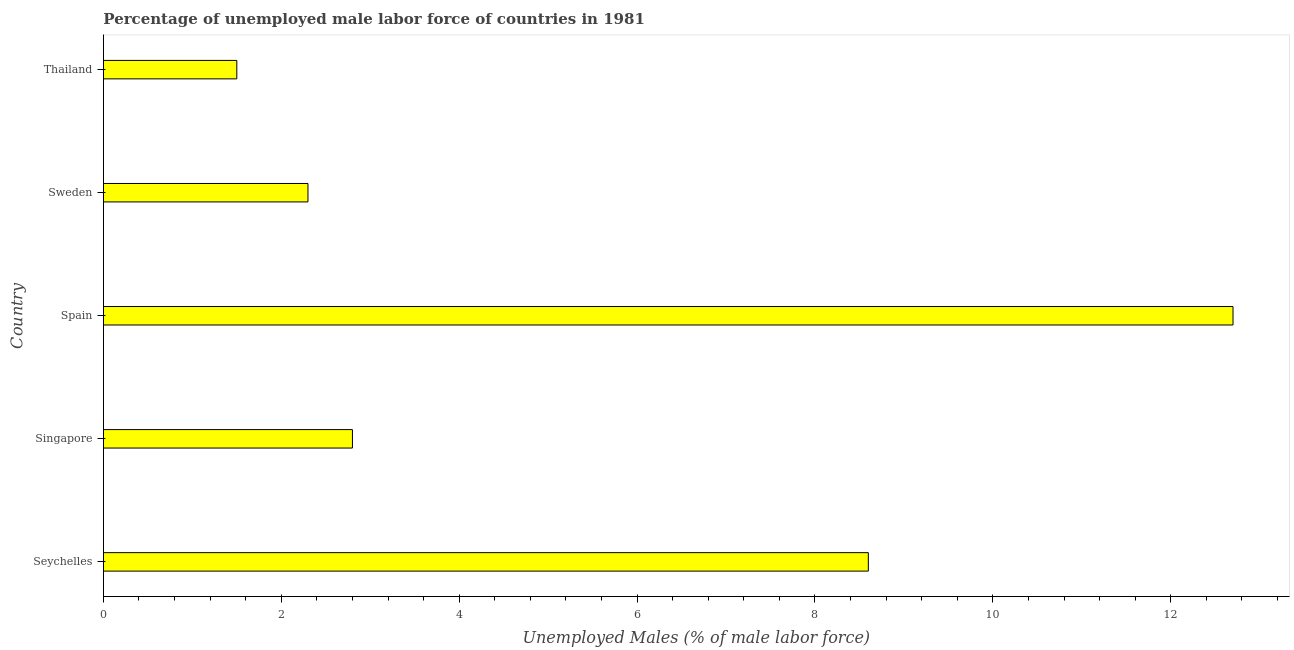Does the graph contain any zero values?
Offer a terse response. No. What is the title of the graph?
Offer a terse response. Percentage of unemployed male labor force of countries in 1981. What is the label or title of the X-axis?
Provide a short and direct response. Unemployed Males (% of male labor force). What is the total unemployed male labour force in Seychelles?
Ensure brevity in your answer.  8.6. Across all countries, what is the maximum total unemployed male labour force?
Your answer should be compact. 12.7. Across all countries, what is the minimum total unemployed male labour force?
Keep it short and to the point. 1.5. In which country was the total unemployed male labour force maximum?
Provide a short and direct response. Spain. In which country was the total unemployed male labour force minimum?
Offer a terse response. Thailand. What is the sum of the total unemployed male labour force?
Your answer should be compact. 27.9. What is the difference between the total unemployed male labour force in Sweden and Thailand?
Your answer should be compact. 0.8. What is the average total unemployed male labour force per country?
Ensure brevity in your answer.  5.58. What is the median total unemployed male labour force?
Offer a very short reply. 2.8. What is the ratio of the total unemployed male labour force in Seychelles to that in Thailand?
Provide a succinct answer. 5.73. Is the total unemployed male labour force in Spain less than that in Sweden?
Provide a succinct answer. No. Is the difference between the total unemployed male labour force in Singapore and Sweden greater than the difference between any two countries?
Make the answer very short. No. Is the sum of the total unemployed male labour force in Singapore and Spain greater than the maximum total unemployed male labour force across all countries?
Offer a terse response. Yes. What is the difference between the highest and the lowest total unemployed male labour force?
Make the answer very short. 11.2. In how many countries, is the total unemployed male labour force greater than the average total unemployed male labour force taken over all countries?
Your response must be concise. 2. How many bars are there?
Offer a very short reply. 5. Are the values on the major ticks of X-axis written in scientific E-notation?
Provide a short and direct response. No. What is the Unemployed Males (% of male labor force) in Seychelles?
Your response must be concise. 8.6. What is the Unemployed Males (% of male labor force) in Singapore?
Make the answer very short. 2.8. What is the Unemployed Males (% of male labor force) in Spain?
Your response must be concise. 12.7. What is the Unemployed Males (% of male labor force) of Sweden?
Keep it short and to the point. 2.3. What is the Unemployed Males (% of male labor force) of Thailand?
Offer a terse response. 1.5. What is the difference between the Unemployed Males (% of male labor force) in Seychelles and Singapore?
Provide a short and direct response. 5.8. What is the difference between the Unemployed Males (% of male labor force) in Seychelles and Thailand?
Ensure brevity in your answer.  7.1. What is the difference between the Unemployed Males (% of male labor force) in Singapore and Spain?
Ensure brevity in your answer.  -9.9. What is the difference between the Unemployed Males (% of male labor force) in Spain and Sweden?
Make the answer very short. 10.4. What is the difference between the Unemployed Males (% of male labor force) in Spain and Thailand?
Keep it short and to the point. 11.2. What is the difference between the Unemployed Males (% of male labor force) in Sweden and Thailand?
Ensure brevity in your answer.  0.8. What is the ratio of the Unemployed Males (% of male labor force) in Seychelles to that in Singapore?
Provide a short and direct response. 3.07. What is the ratio of the Unemployed Males (% of male labor force) in Seychelles to that in Spain?
Your answer should be compact. 0.68. What is the ratio of the Unemployed Males (% of male labor force) in Seychelles to that in Sweden?
Offer a very short reply. 3.74. What is the ratio of the Unemployed Males (% of male labor force) in Seychelles to that in Thailand?
Ensure brevity in your answer.  5.73. What is the ratio of the Unemployed Males (% of male labor force) in Singapore to that in Spain?
Provide a short and direct response. 0.22. What is the ratio of the Unemployed Males (% of male labor force) in Singapore to that in Sweden?
Give a very brief answer. 1.22. What is the ratio of the Unemployed Males (% of male labor force) in Singapore to that in Thailand?
Offer a terse response. 1.87. What is the ratio of the Unemployed Males (% of male labor force) in Spain to that in Sweden?
Provide a succinct answer. 5.52. What is the ratio of the Unemployed Males (% of male labor force) in Spain to that in Thailand?
Give a very brief answer. 8.47. What is the ratio of the Unemployed Males (% of male labor force) in Sweden to that in Thailand?
Provide a succinct answer. 1.53. 